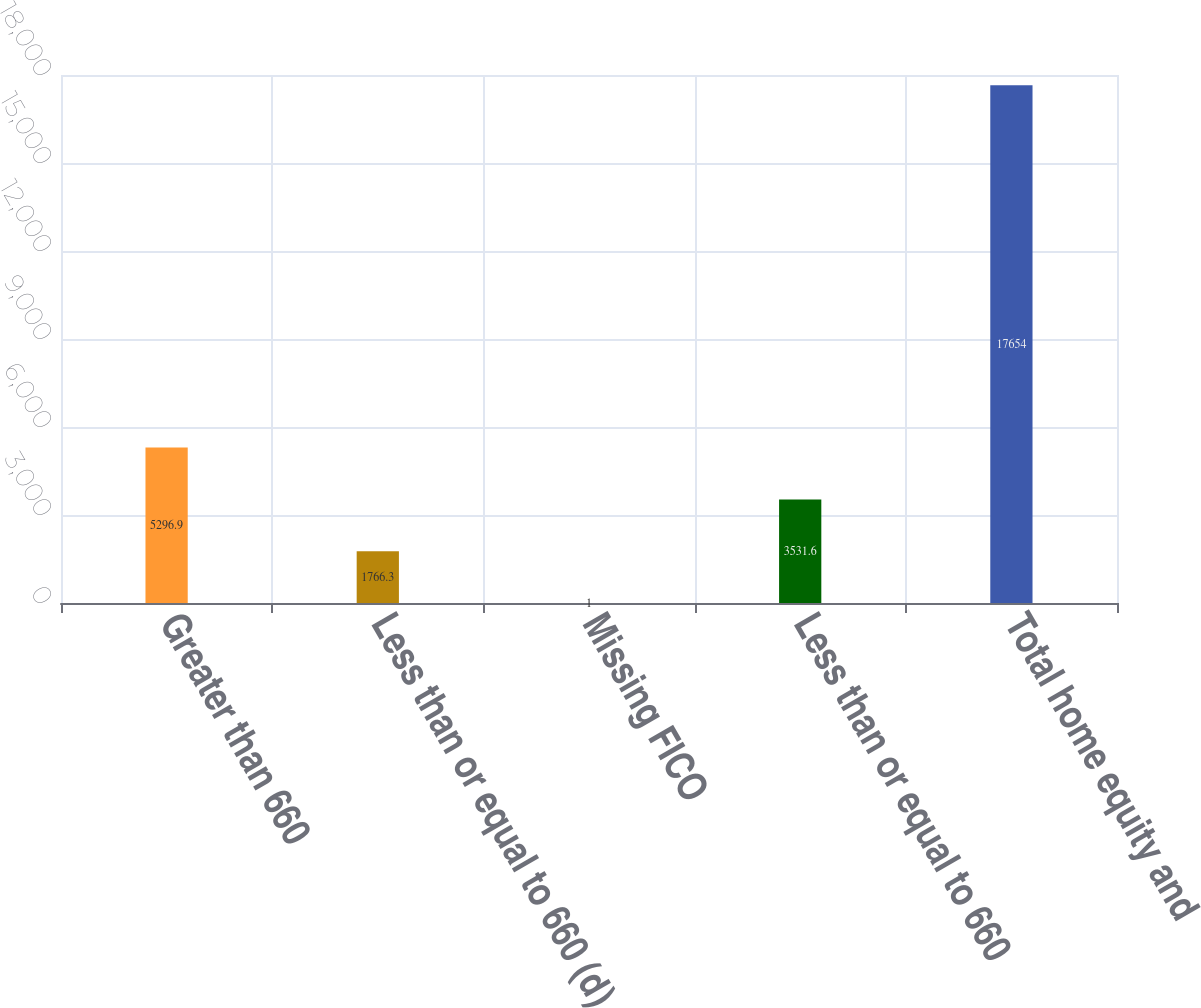Convert chart to OTSL. <chart><loc_0><loc_0><loc_500><loc_500><bar_chart><fcel>Greater than 660<fcel>Less than or equal to 660 (d)<fcel>Missing FICO<fcel>Less than or equal to 660<fcel>Total home equity and<nl><fcel>5296.9<fcel>1766.3<fcel>1<fcel>3531.6<fcel>17654<nl></chart> 